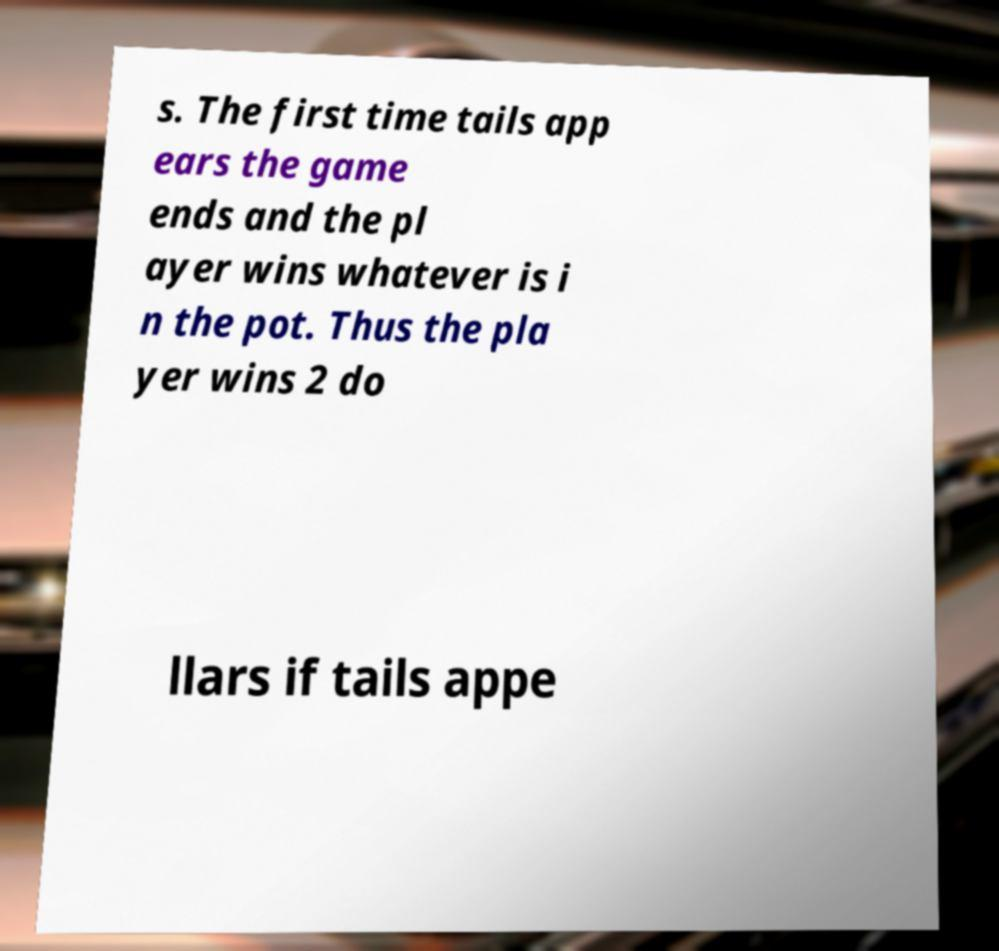Can you read and provide the text displayed in the image?This photo seems to have some interesting text. Can you extract and type it out for me? s. The first time tails app ears the game ends and the pl ayer wins whatever is i n the pot. Thus the pla yer wins 2 do llars if tails appe 